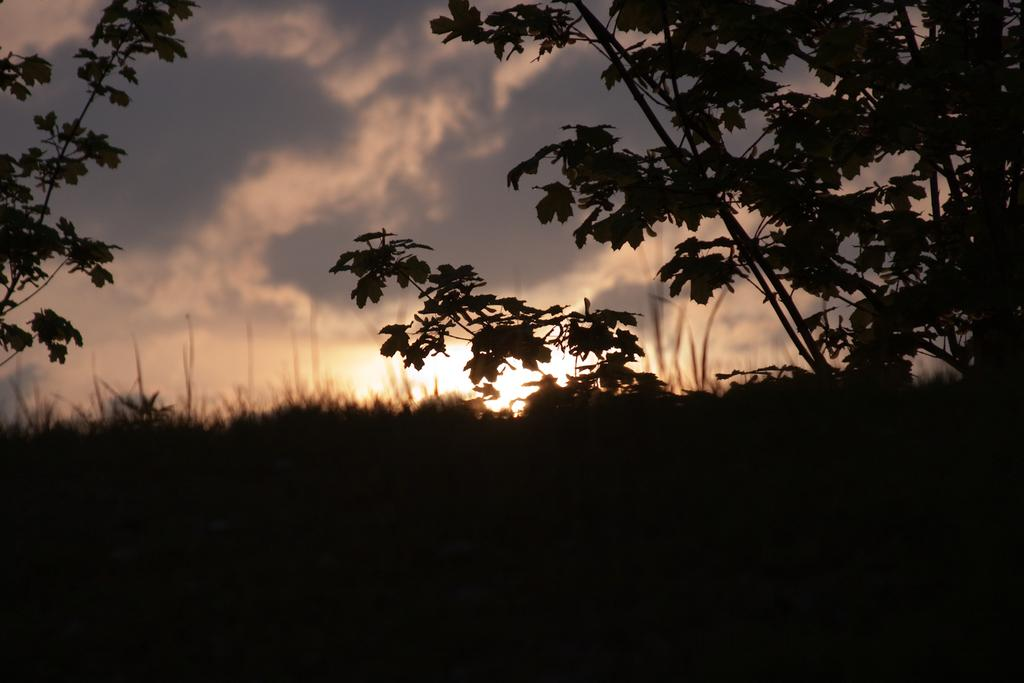What type of living organisms can be seen in the image? Plants can be seen in the image. What is visible at the top of the image? The sky is visible at the top of the image. What can be observed about the bottom of the image? The bottom of the image appears to be dark. What is the hen's desire in the image? There is no hen present in the image, so it is not possible to determine its desires. 